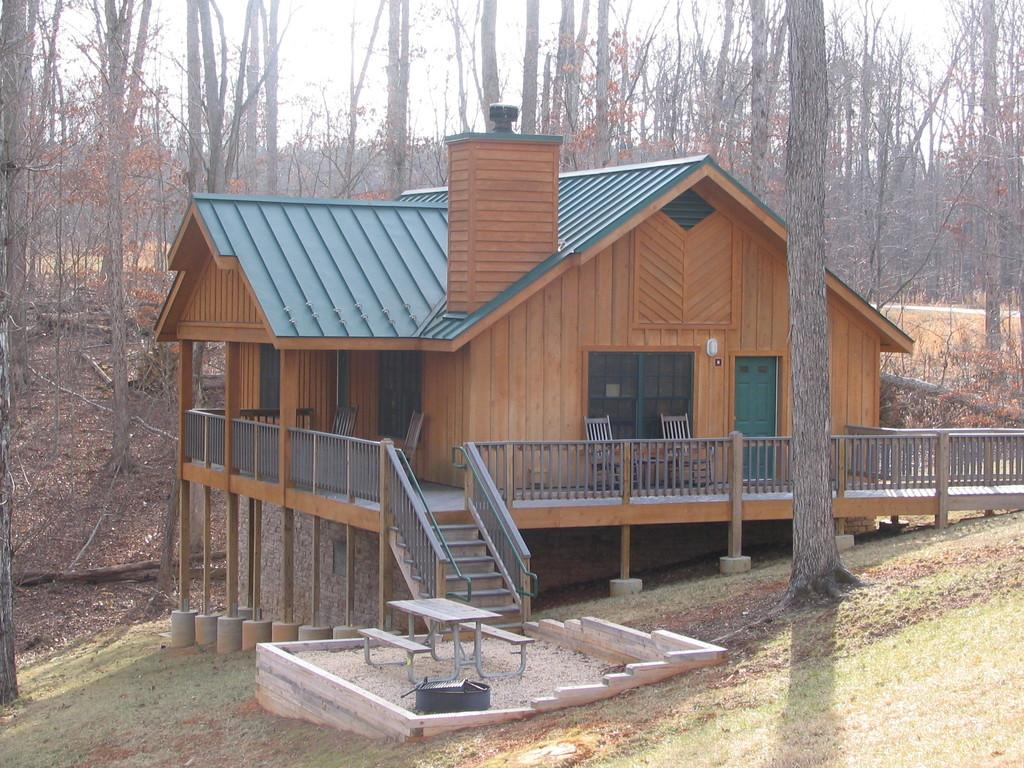What type of vegetation is present in the image? There is grass in the image. What type of furniture can be seen in the image? There is a table and chairs in the image. What type of structure is visible in the image? There is a house with stairs, doors, and windows in the image. What can be seen in the background of the image? There are trees in the background of the image. Can you see any flesh or a crown in the image? No, there is no flesh or crown present in the image. What type of bed can be seen in the image? There is no bed present in the image. 